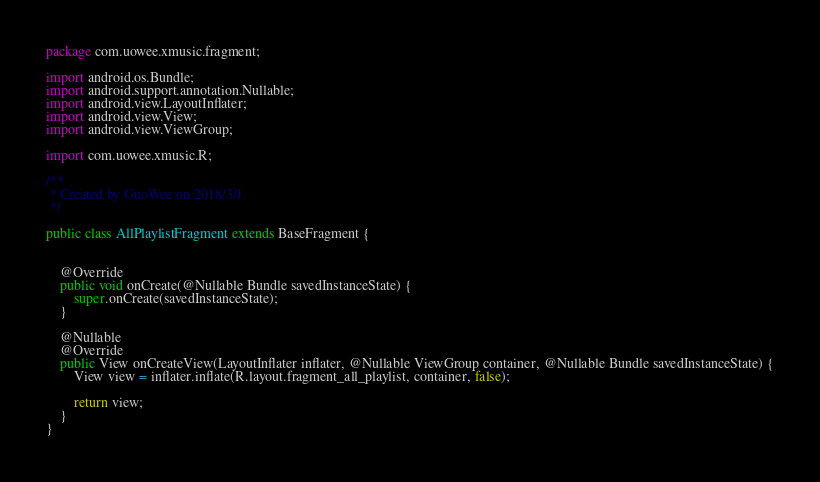Convert code to text. <code><loc_0><loc_0><loc_500><loc_500><_Java_>package com.uowee.xmusic.fragment;

import android.os.Bundle;
import android.support.annotation.Nullable;
import android.view.LayoutInflater;
import android.view.View;
import android.view.ViewGroup;

import com.uowee.xmusic.R;

/**
 * Created by GuoWee on 2018/3/1.
 */

public class AllPlaylistFragment extends BaseFragment {


    @Override
    public void onCreate(@Nullable Bundle savedInstanceState) {
        super.onCreate(savedInstanceState);
    }

    @Nullable
    @Override
    public View onCreateView(LayoutInflater inflater, @Nullable ViewGroup container, @Nullable Bundle savedInstanceState) {
        View view = inflater.inflate(R.layout.fragment_all_playlist, container, false);

        return view;
    }
}
</code> 